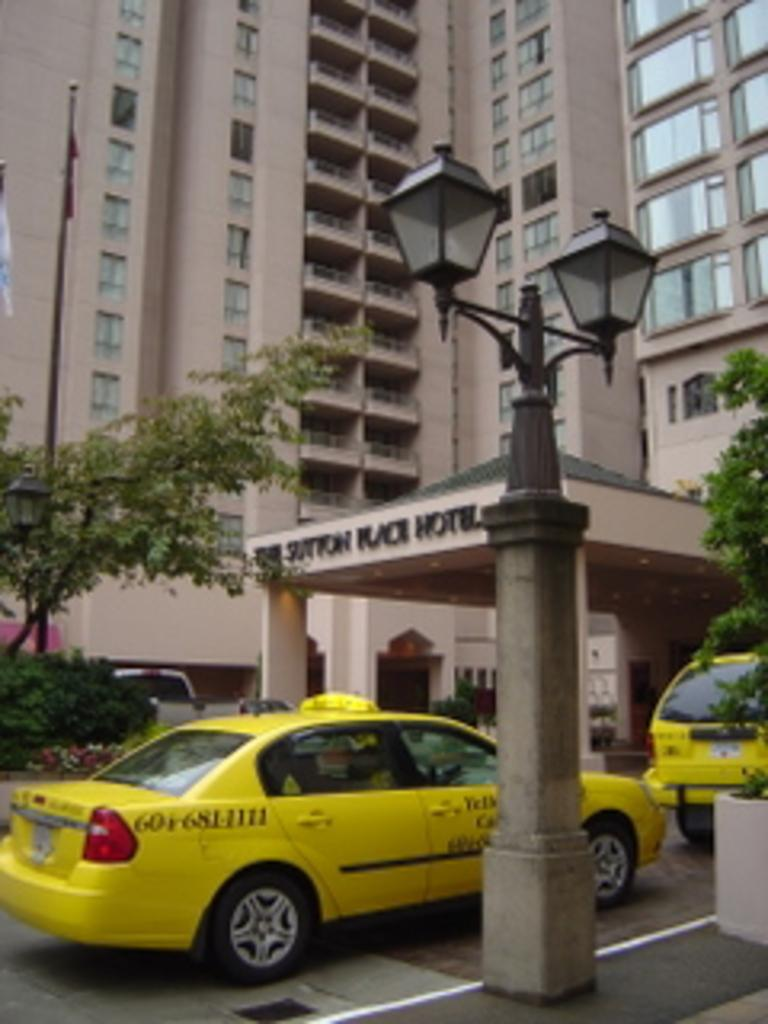Provide a one-sentence caption for the provided image. The end of the phone number for the taxi pulling up to the hotel is 1111. 